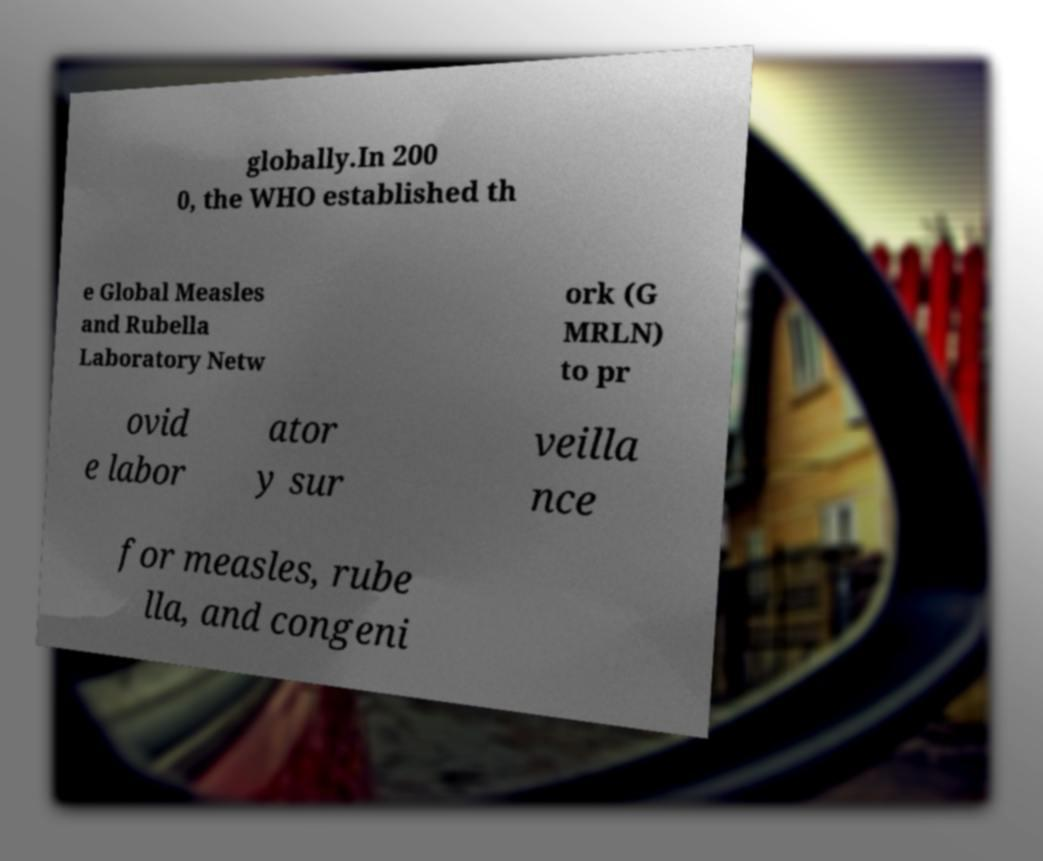Please identify and transcribe the text found in this image. globally.In 200 0, the WHO established th e Global Measles and Rubella Laboratory Netw ork (G MRLN) to pr ovid e labor ator y sur veilla nce for measles, rube lla, and congeni 